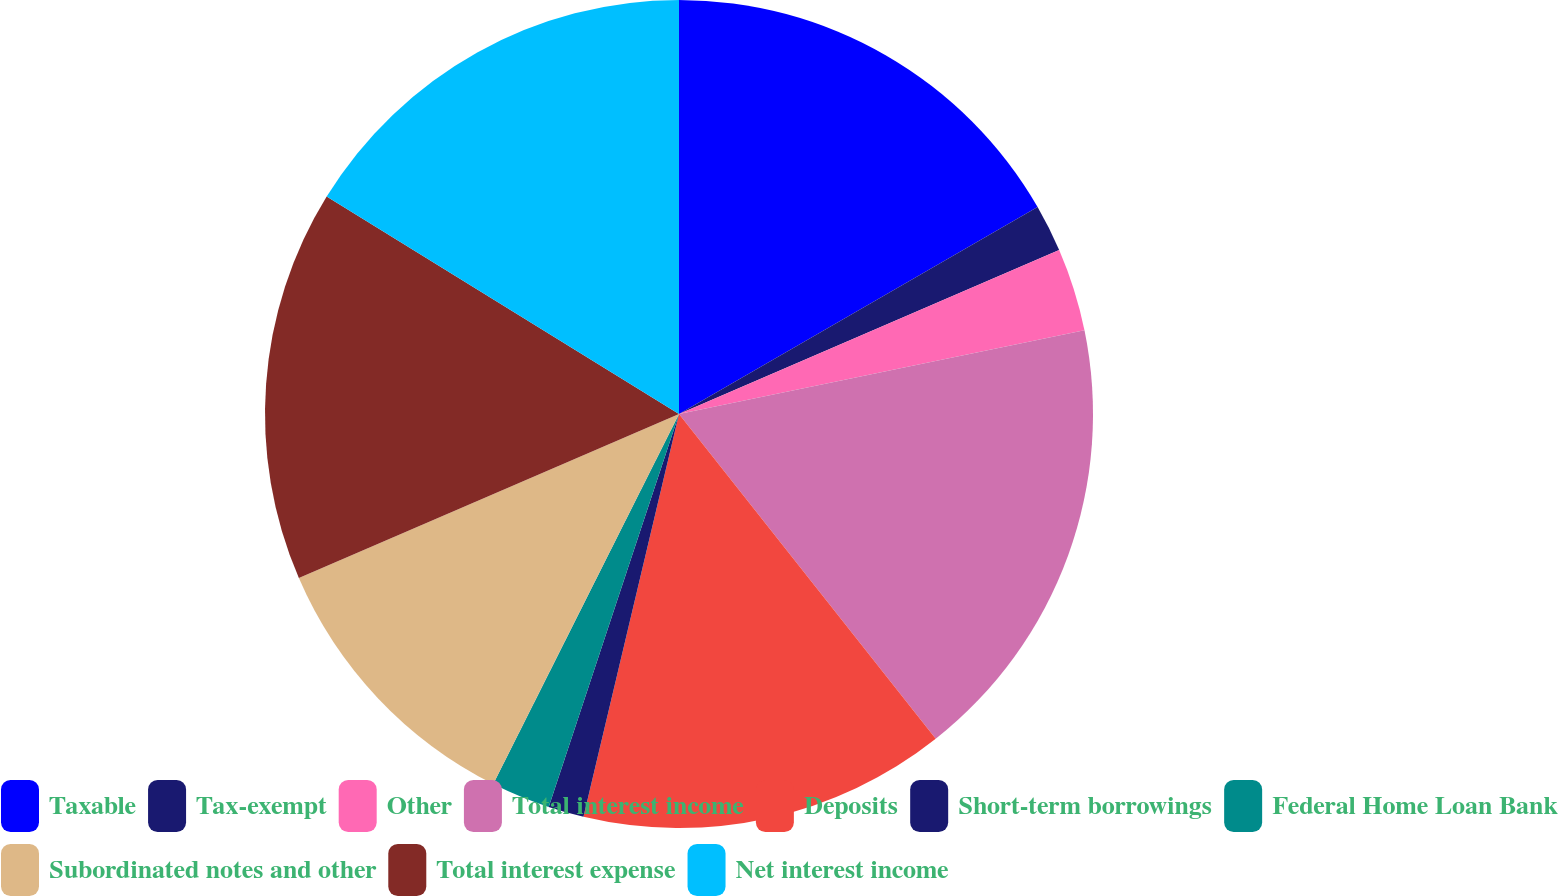<chart> <loc_0><loc_0><loc_500><loc_500><pie_chart><fcel>Taxable<fcel>Tax-exempt<fcel>Other<fcel>Total interest income<fcel>Deposits<fcel>Short-term borrowings<fcel>Federal Home Loan Bank<fcel>Subordinated notes and other<fcel>Total interest expense<fcel>Net interest income<nl><fcel>16.67%<fcel>1.85%<fcel>3.24%<fcel>17.59%<fcel>14.35%<fcel>1.39%<fcel>2.31%<fcel>11.11%<fcel>15.28%<fcel>16.2%<nl></chart> 